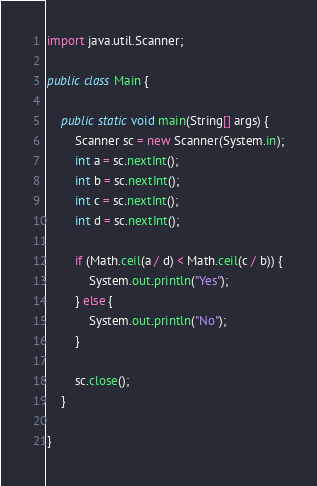<code> <loc_0><loc_0><loc_500><loc_500><_Java_>import java.util.Scanner;

public class Main {

	public static void main(String[] args) {
		Scanner sc = new Scanner(System.in);
		int a = sc.nextInt();
		int b = sc.nextInt();
		int c = sc.nextInt();
		int d = sc.nextInt();

		if (Math.ceil(a / d) < Math.ceil(c / b)) {
			System.out.println("Yes");
		} else {
			System.out.println("No");
		}

		sc.close();
	}

}
</code> 